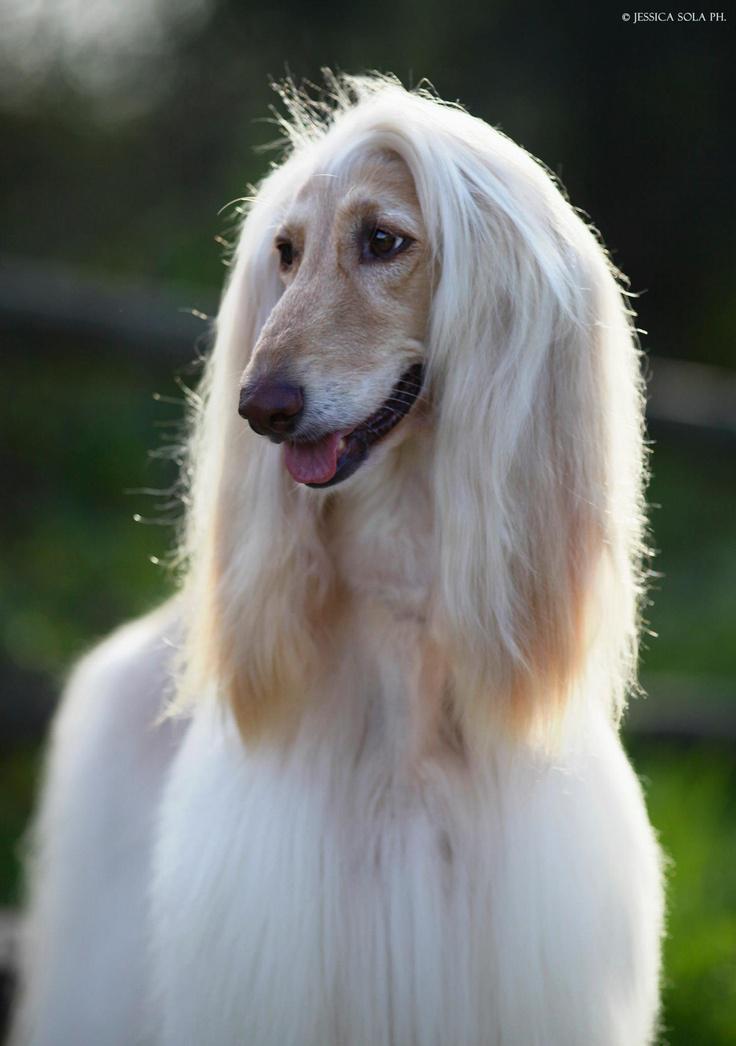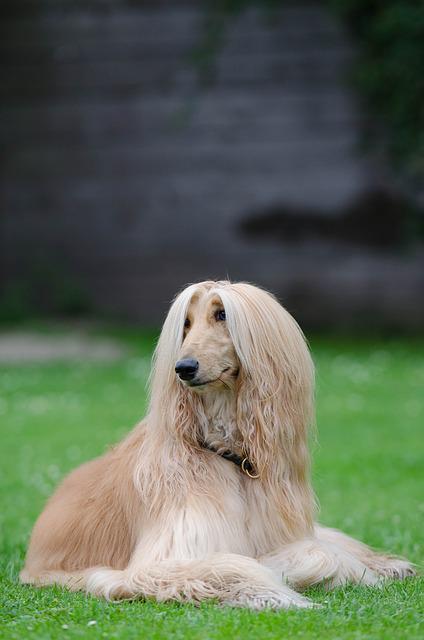The first image is the image on the left, the second image is the image on the right. Evaluate the accuracy of this statement regarding the images: "An image clearly shows a 'blond' long-haired hound that is on the grass but not standing.". Is it true? Answer yes or no. Yes. The first image is the image on the left, the second image is the image on the right. Analyze the images presented: Is the assertion "The dog in the image on the left is taking strides as it walks outside." valid? Answer yes or no. No. 